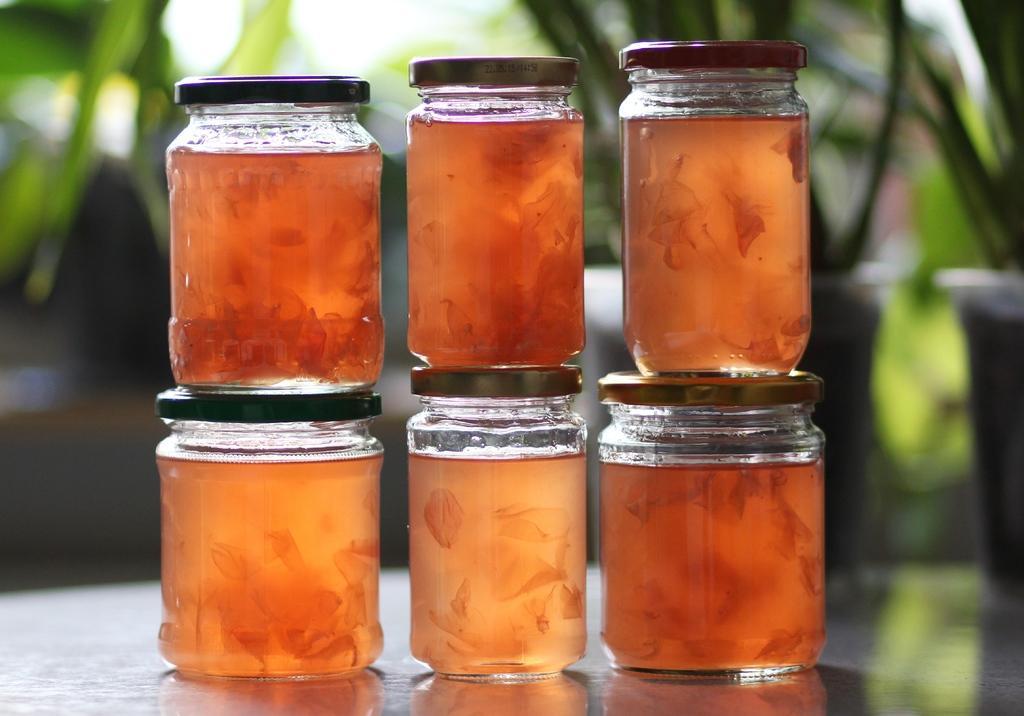Please provide a concise description of this image. This six jars are highlighted in this picture. 